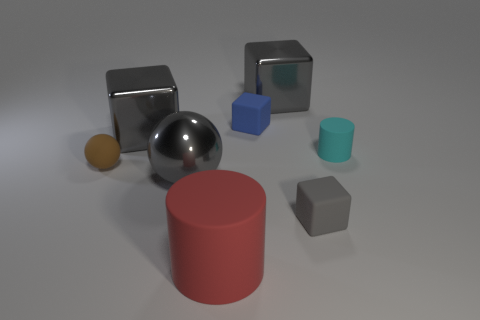How many other things are the same size as the red rubber thing? 3 